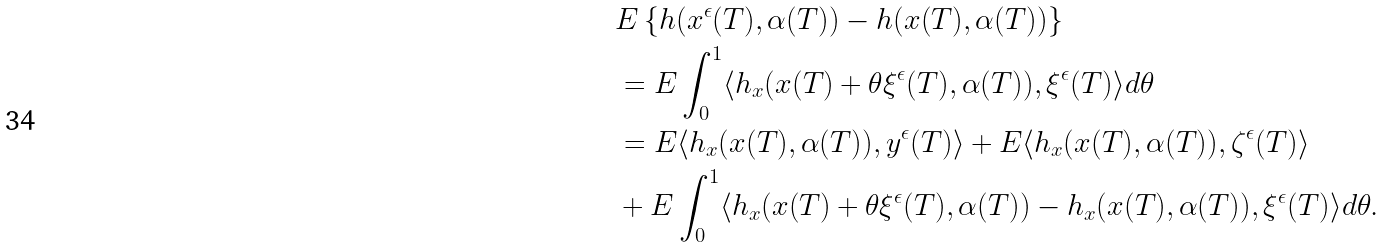Convert formula to latex. <formula><loc_0><loc_0><loc_500><loc_500>& E \left \{ h ( x ^ { \epsilon } ( T ) , \alpha ( T ) ) - h ( x ( T ) , \alpha ( T ) ) \right \} \\ & = E \int ^ { 1 } _ { 0 } \langle h _ { x } ( x ( T ) + \theta \xi ^ { \epsilon } ( T ) , \alpha ( T ) ) , \xi ^ { \epsilon } ( T ) \rangle d \theta \\ & = E \langle h _ { x } ( x ( T ) , \alpha ( T ) ) , y ^ { \epsilon } ( T ) \rangle + E \langle h _ { x } ( x ( T ) , \alpha ( T ) ) , \zeta ^ { \epsilon } ( T ) \rangle \\ & + E \int ^ { 1 } _ { 0 } \langle h _ { x } ( x ( T ) + \theta \xi ^ { \epsilon } ( T ) , \alpha ( T ) ) - h _ { x } ( x ( T ) , \alpha ( T ) ) , \xi ^ { \epsilon } ( T ) \rangle d \theta .</formula> 